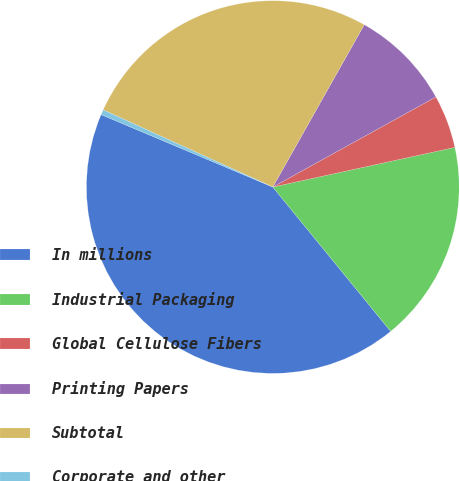Convert chart to OTSL. <chart><loc_0><loc_0><loc_500><loc_500><pie_chart><fcel>In millions<fcel>Industrial Packaging<fcel>Global Cellulose Fibers<fcel>Printing Papers<fcel>Subtotal<fcel>Corporate and other<nl><fcel>42.25%<fcel>17.51%<fcel>4.62%<fcel>8.8%<fcel>26.37%<fcel>0.44%<nl></chart> 